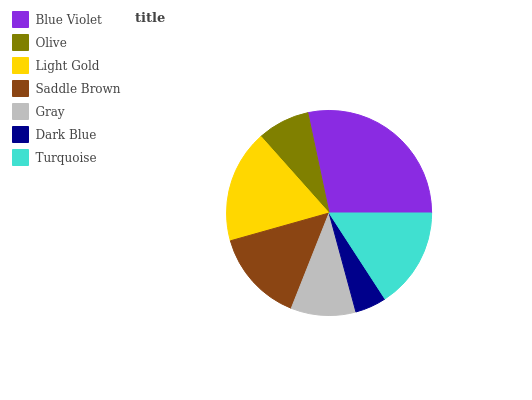Is Dark Blue the minimum?
Answer yes or no. Yes. Is Blue Violet the maximum?
Answer yes or no. Yes. Is Olive the minimum?
Answer yes or no. No. Is Olive the maximum?
Answer yes or no. No. Is Blue Violet greater than Olive?
Answer yes or no. Yes. Is Olive less than Blue Violet?
Answer yes or no. Yes. Is Olive greater than Blue Violet?
Answer yes or no. No. Is Blue Violet less than Olive?
Answer yes or no. No. Is Saddle Brown the high median?
Answer yes or no. Yes. Is Saddle Brown the low median?
Answer yes or no. Yes. Is Turquoise the high median?
Answer yes or no. No. Is Light Gold the low median?
Answer yes or no. No. 